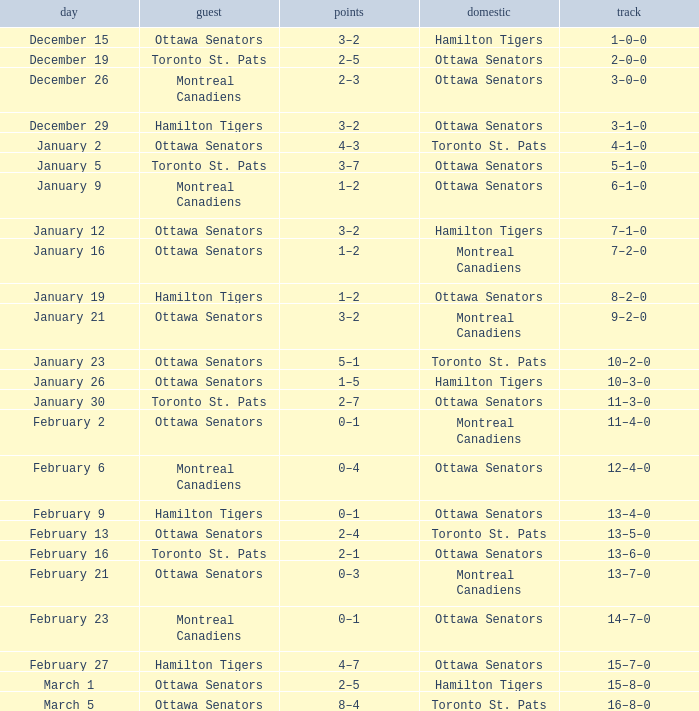Which home team had a visitor of Ottawa Senators with a score of 1–5? Hamilton Tigers. 